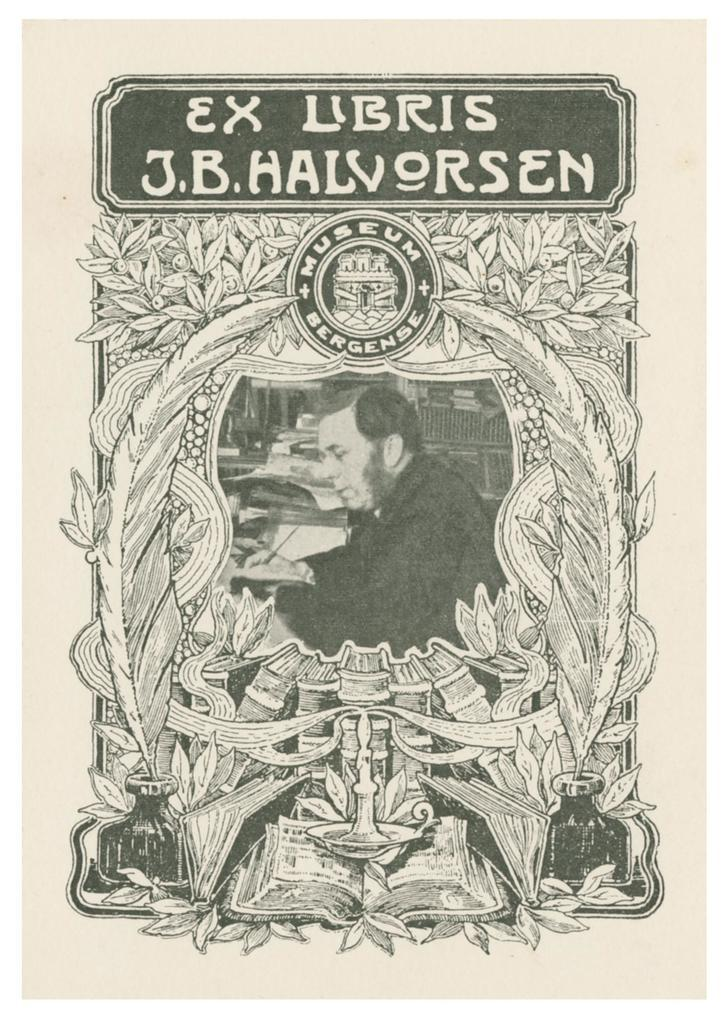<image>
Offer a succinct explanation of the picture presented. A man on a cover of Ex Libris J.B. Halvornsen. 